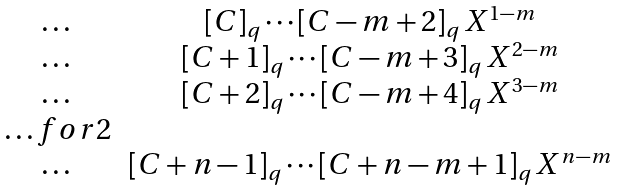Convert formula to latex. <formula><loc_0><loc_0><loc_500><loc_500>\begin{matrix} \dots & [ C ] _ { q } \cdots [ C - m + 2 ] _ { q } \, X ^ { 1 - m } \\ \dots & [ C + 1 ] _ { q } \cdots [ C - m + 3 ] _ { q } \, X ^ { 2 - m } \\ \dots & [ C + 2 ] _ { q } \cdots [ C - m + 4 ] _ { q } \, X ^ { 3 - m } \\ \hdots f o r 2 \\ \dots & [ C + n - 1 ] _ { q } \cdots [ C + n - m + 1 ] _ { q } \, X ^ { n - m } \end{matrix}</formula> 